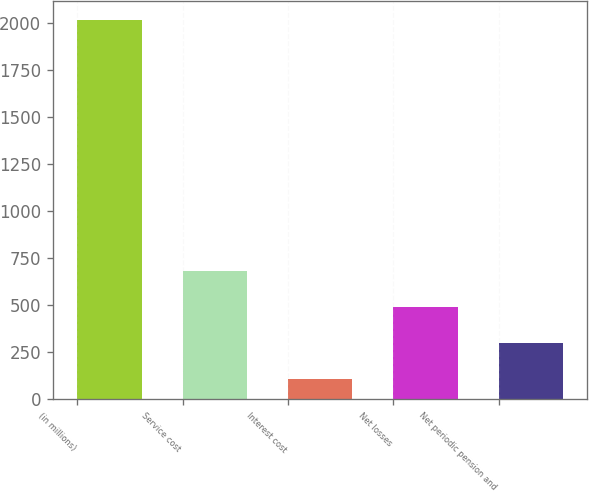<chart> <loc_0><loc_0><loc_500><loc_500><bar_chart><fcel>(in millions)<fcel>Service cost<fcel>Interest cost<fcel>Net losses<fcel>Net periodic pension and<nl><fcel>2018<fcel>681.7<fcel>109<fcel>490.8<fcel>299.9<nl></chart> 